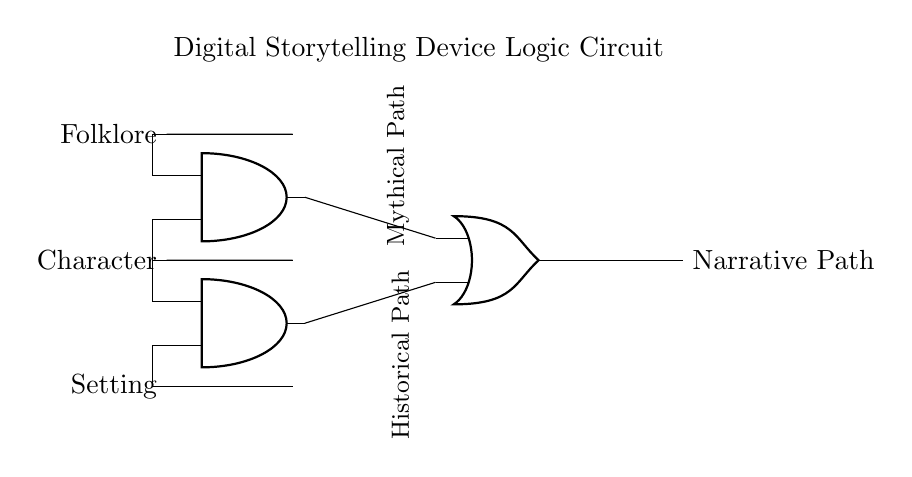What are the inputs in this circuit? The inputs are Folklore, Character, and Setting, which are connected to the logic gates at the left side of the diagram.
Answer: Folklore, Character, Setting How many AND gates are present in this circuit? There are two AND gates, as indicated by the two distinct AND gate symbols drawn in the circuit diagram.
Answer: 2 What is the output of the OR gate? The output of the OR gate is the Narrative Path, represented at the end of the circuit diagram as a single output flowing from the OR gate.
Answer: Narrative Path Which paths connect to the first AND gate? The paths that connect to the first AND gate are Folklore and Character, shown by their connections leading into the AND gate from the left side.
Answer: Folklore and Character If both inputs to the second AND gate are true, what will be the output? The output will be true, meaning the Narrative Path connected to the output of the OR gate will include the Historical Path when both inputs to the second AND gate (Character and Setting) are true.
Answer: Historical Path What is the role of the OR gate in this circuit? The OR gate acts as a decision point that combines the outputs of the two AND gates and allows the narrative path to switch based on the conditions met by the input combinations.
Answer: Decision point Which narrative paths are represented in this circuit? The circuit represents a Mythical Path and a Historical Path as outputs based on different combinations of inputs through the logic gates.
Answer: Mythical Path, Historical Path 